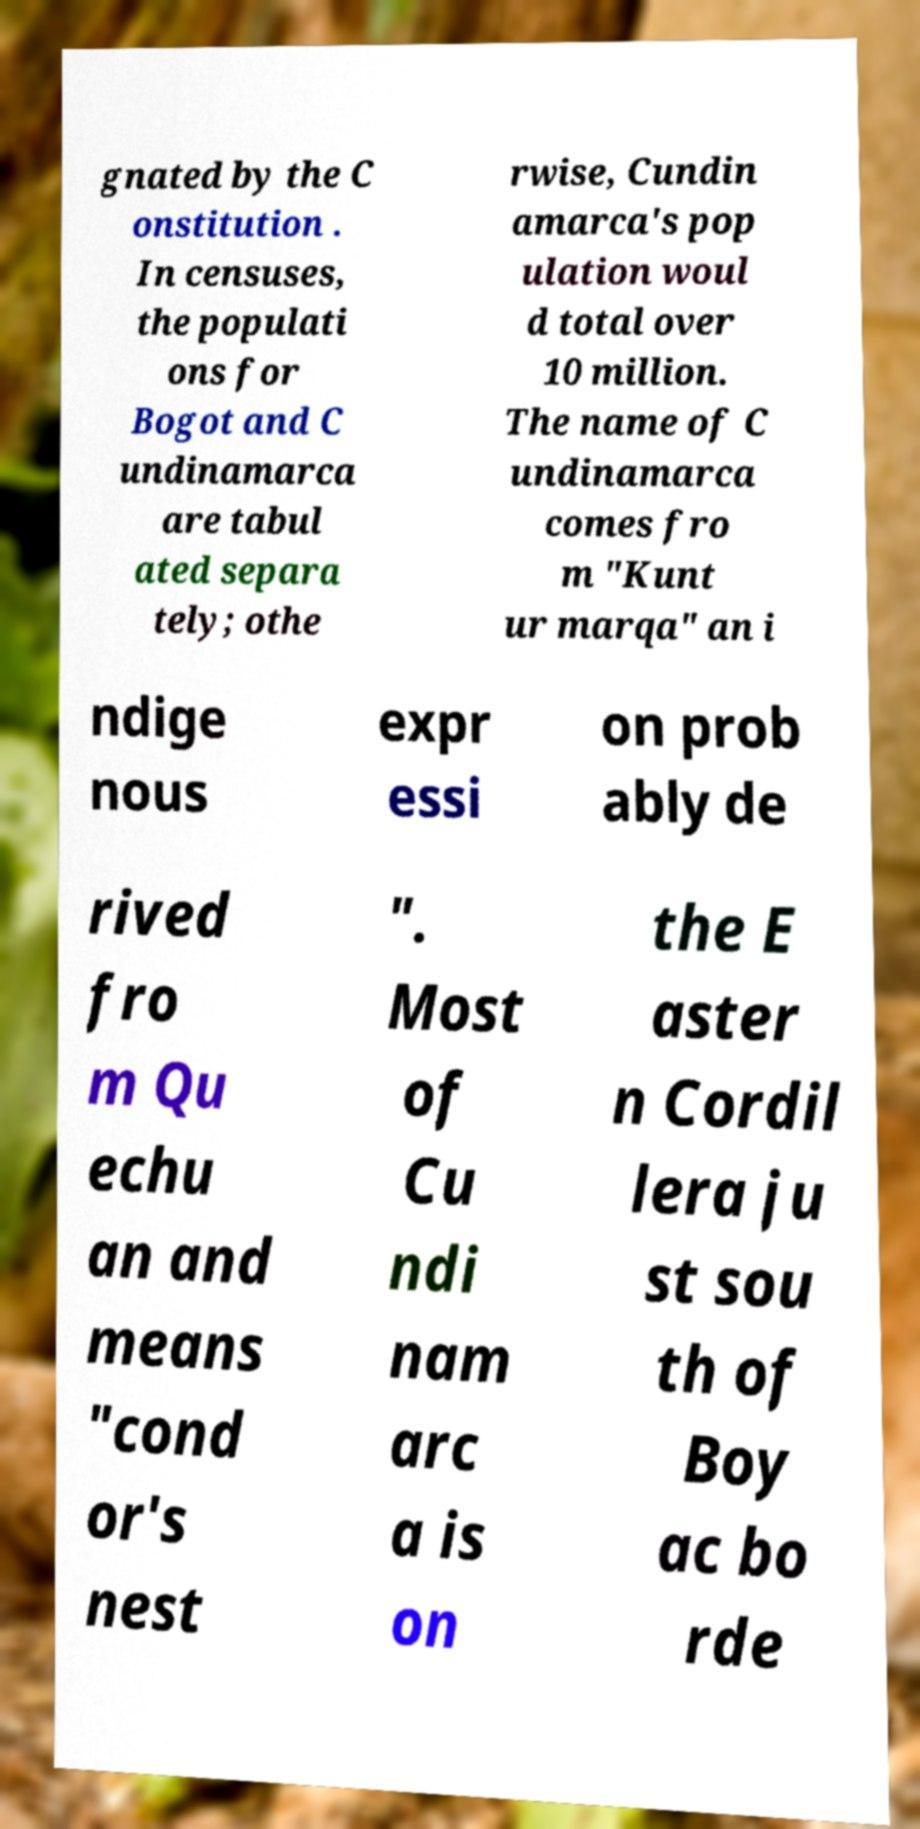There's text embedded in this image that I need extracted. Can you transcribe it verbatim? gnated by the C onstitution . In censuses, the populati ons for Bogot and C undinamarca are tabul ated separa tely; othe rwise, Cundin amarca's pop ulation woul d total over 10 million. The name of C undinamarca comes fro m "Kunt ur marqa" an i ndige nous expr essi on prob ably de rived fro m Qu echu an and means "cond or's nest ". Most of Cu ndi nam arc a is on the E aster n Cordil lera ju st sou th of Boy ac bo rde 